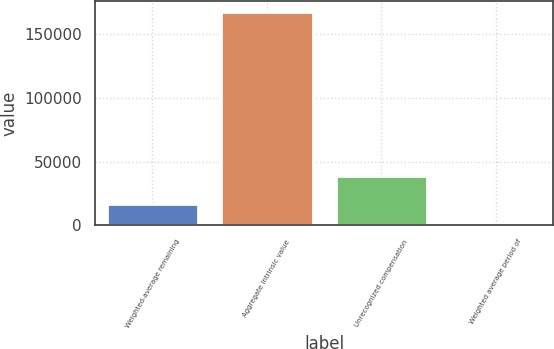Convert chart to OTSL. <chart><loc_0><loc_0><loc_500><loc_500><bar_chart><fcel>Weighted-average remaining<fcel>Aggregate intrinsic value<fcel>Unrecognized compensation<fcel>Weighted average period of<nl><fcel>16772.1<fcel>167713<fcel>38809<fcel>0.91<nl></chart> 